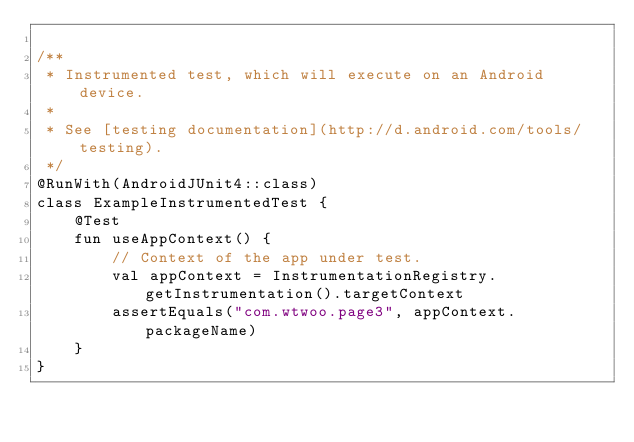<code> <loc_0><loc_0><loc_500><loc_500><_Kotlin_>
/**
 * Instrumented test, which will execute on an Android device.
 *
 * See [testing documentation](http://d.android.com/tools/testing).
 */
@RunWith(AndroidJUnit4::class)
class ExampleInstrumentedTest {
    @Test
    fun useAppContext() {
        // Context of the app under test.
        val appContext = InstrumentationRegistry.getInstrumentation().targetContext
        assertEquals("com.wtwoo.page3", appContext.packageName)
    }
}</code> 